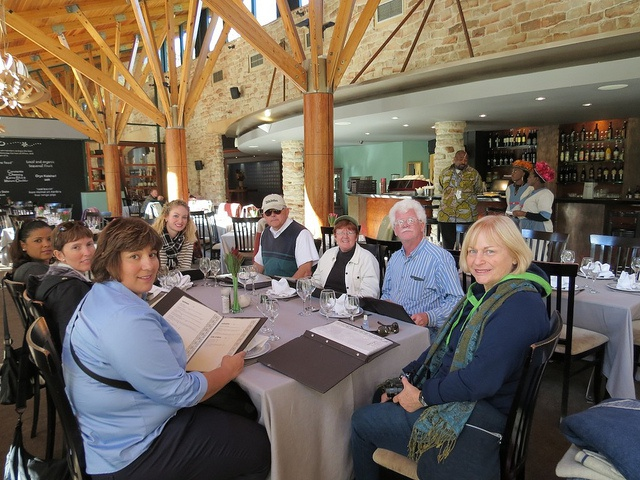Describe the objects in this image and their specific colors. I can see people in tan, black, darkgray, and gray tones, people in tan, black, navy, and gray tones, people in tan, darkgray, and gray tones, dining table in tan, gray, darkgray, and lavender tones, and dining table in tan, darkgray, and gray tones in this image. 